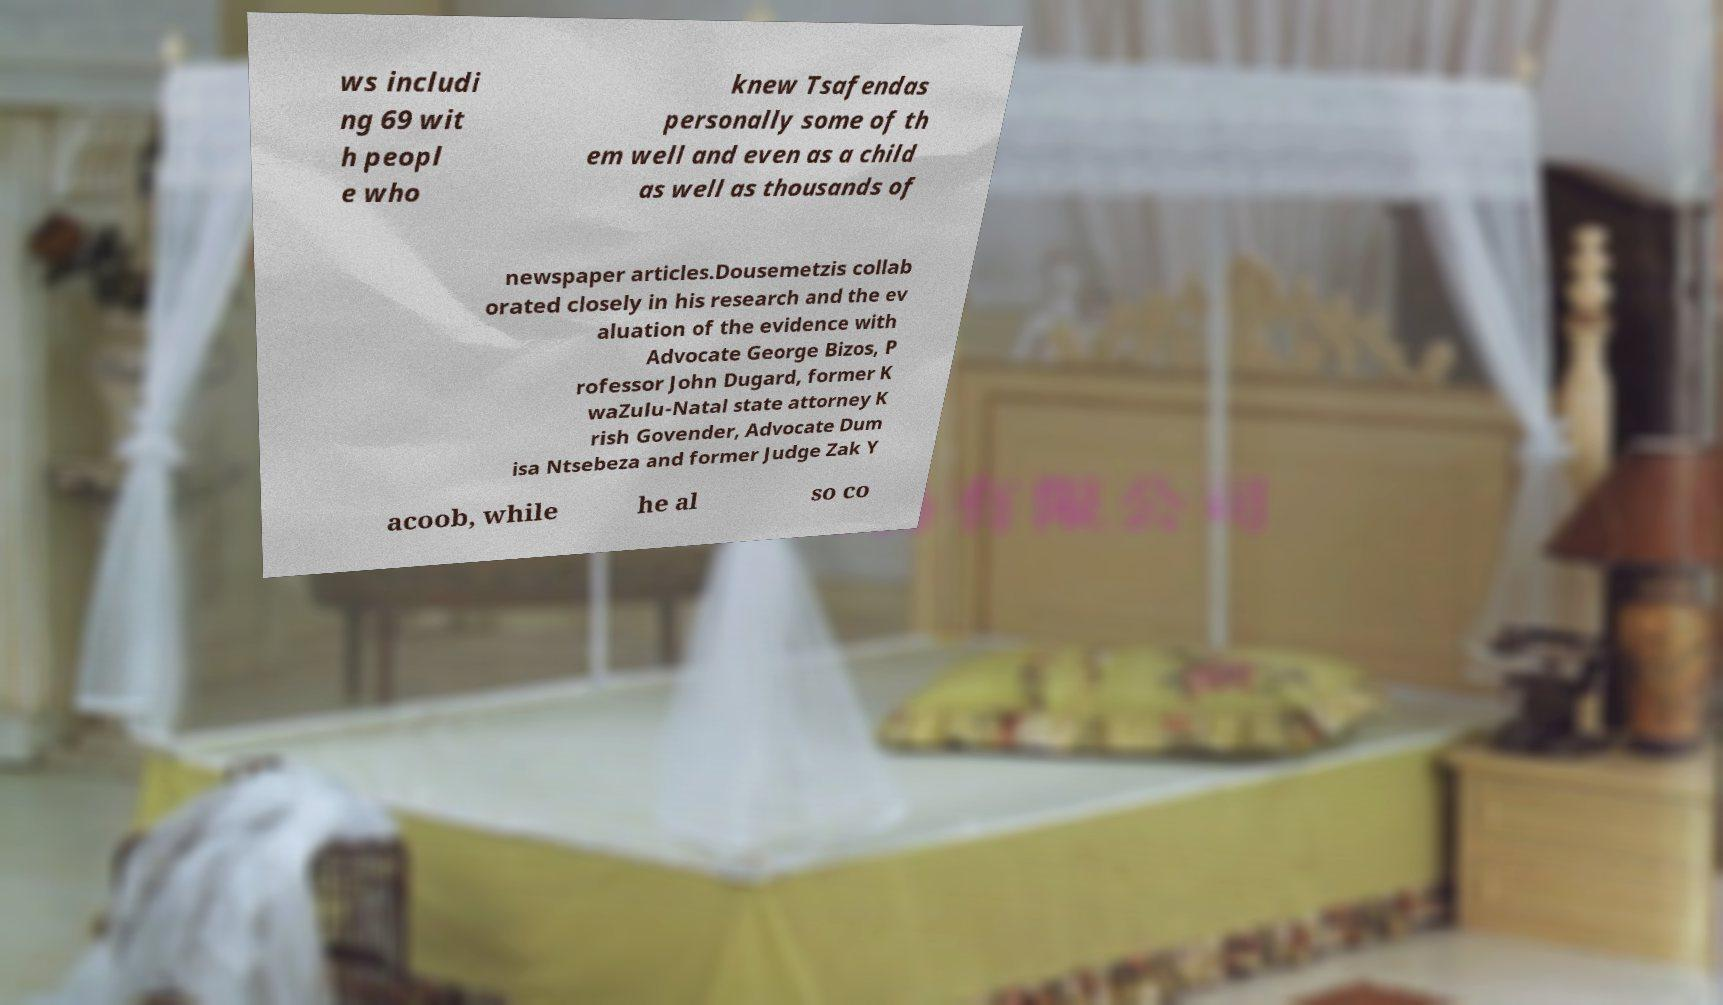Please read and relay the text visible in this image. What does it say? ws includi ng 69 wit h peopl e who knew Tsafendas personally some of th em well and even as a child as well as thousands of newspaper articles.Dousemetzis collab orated closely in his research and the ev aluation of the evidence with Advocate George Bizos, P rofessor John Dugard, former K waZulu-Natal state attorney K rish Govender, Advocate Dum isa Ntsebeza and former Judge Zak Y acoob, while he al so co 